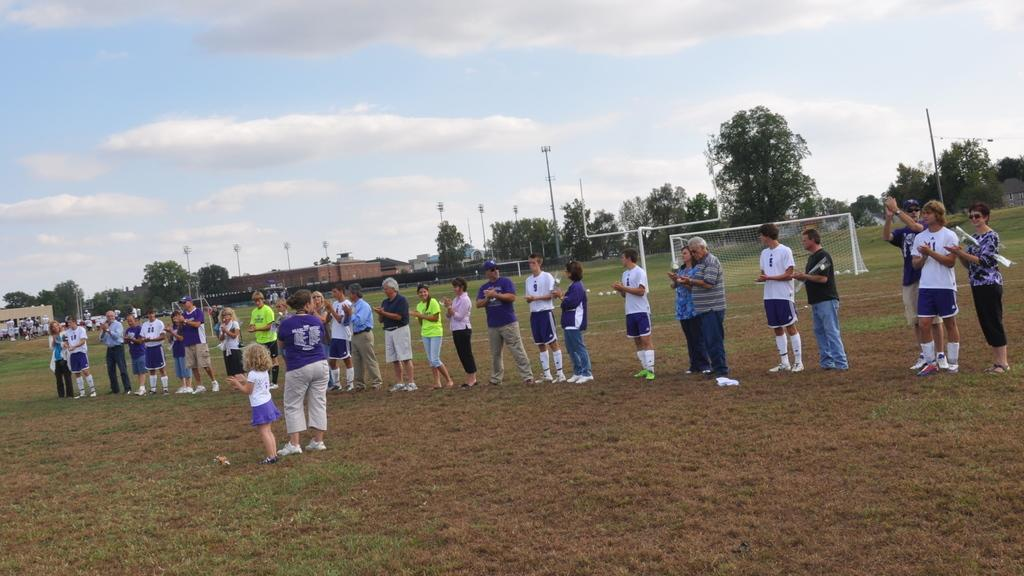What is happening in the foreground area of the image? There are people standing in the foreground area of the image. What type of terrain are the people standing on? The people are standing on grassland. What can be seen in the background area of the image? There are poles, trees, houses, a net, and the sky visible in the background area of the image. What type of skirt is the train wearing in the image? There is no train or skirt present in the image. How does the regret affect the people in the image? There is no mention of regret in the image, so it cannot affect the people in the image. 